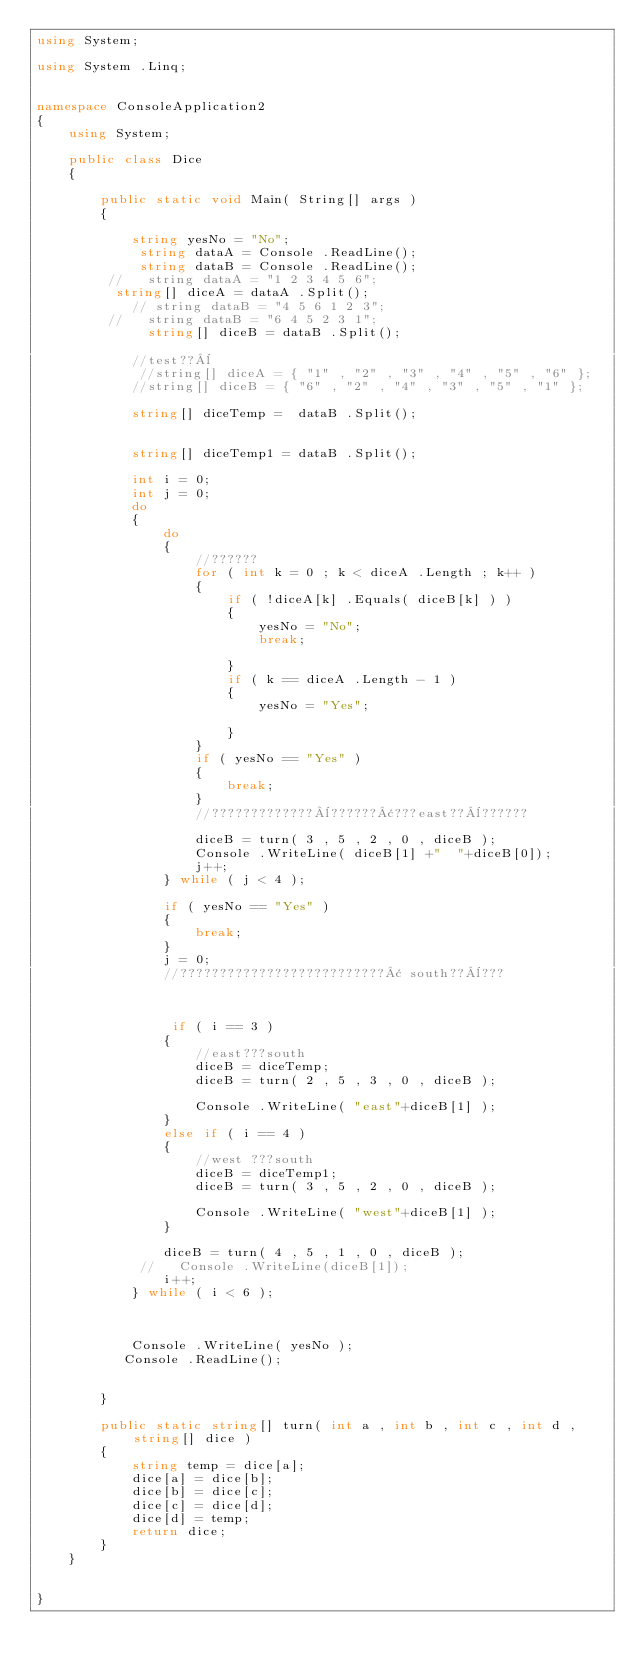<code> <loc_0><loc_0><loc_500><loc_500><_C#_>using System;

using System .Linq;


namespace ConsoleApplication2
{
    using System;

    public class Dice
    {

        public static void Main( String[] args )
        {

            string yesNo = "No";
             string dataA = Console .ReadLine();
             string dataB = Console .ReadLine();
         //   string dataA = "1 2 3 4 5 6";
          string[] diceA = dataA .Split();
            // string dataB = "4 5 6 1 2 3";
         //   string dataB = "6 4 5 2 3 1";
              string[] diceB = dataB .Split();

            //test??¨
             //string[] diceA = { "1" , "2" , "3" , "4" , "5" , "6" };
            //string[] diceB = { "6" , "2" , "4" , "3" , "5" , "1" };

            string[] diceTemp =  dataB .Split();
            
              
            string[] diceTemp1 = dataB .Split();

            int i = 0;
            int j = 0;
            do
            {
                do
                {
                    //??????
                    for ( int k = 0 ; k < diceA .Length ; k++ )
                    {
                        if ( !diceA[k] .Equals( diceB[k] ) )
                        {
                            yesNo = "No";
                            break;

                        }
                        if ( k == diceA .Length - 1 )
                        {
                            yesNo = "Yes";

                        }
                    }
                    if ( yesNo == "Yes" )
                    {
                        break;
                    }
                    //?????????????¨??????¢???east??¨??????

                    diceB = turn( 3 , 5 , 2 , 0 , diceB );
                    Console .WriteLine( diceB[1] +"  "+diceB[0]);
                    j++;
                } while ( j < 4 );

                if ( yesNo == "Yes" )
                {
                    break;
                }
                j = 0;
                //??????????????????????????¢ south??¨???


                
                 if ( i == 3 )
                {
                    //east???south
                    diceB = diceTemp;
                    diceB = turn( 2 , 5 , 3 , 0 , diceB );

                    Console .WriteLine( "east"+diceB[1] );
                }
                else if ( i == 4 )
                {
                    //west ???south
                    diceB = diceTemp1;
                    diceB = turn( 3 , 5 , 2 , 0 , diceB );
                    
                    Console .WriteLine( "west"+diceB[1] );
                }

                diceB = turn( 4 , 5 , 1 , 0 , diceB );
             //   Console .WriteLine(diceB[1]);
                i++;
            } while ( i < 6 );



            Console .WriteLine( yesNo );
           Console .ReadLine();


        }

        public static string[] turn( int a , int b , int c , int d , string[] dice )
        {
            string temp = dice[a];
            dice[a] = dice[b];
            dice[b] = dice[c];
            dice[c] = dice[d];
            dice[d] = temp;
            return dice;
        }
    }


}</code> 